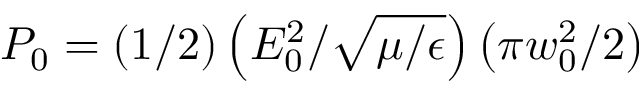Convert formula to latex. <formula><loc_0><loc_0><loc_500><loc_500>P _ { 0 } = ( 1 / 2 ) \left ( E _ { 0 } ^ { 2 } / \sqrt { \mu / \epsilon } \right ) \left ( \pi w _ { 0 } ^ { 2 } / 2 \right )</formula> 